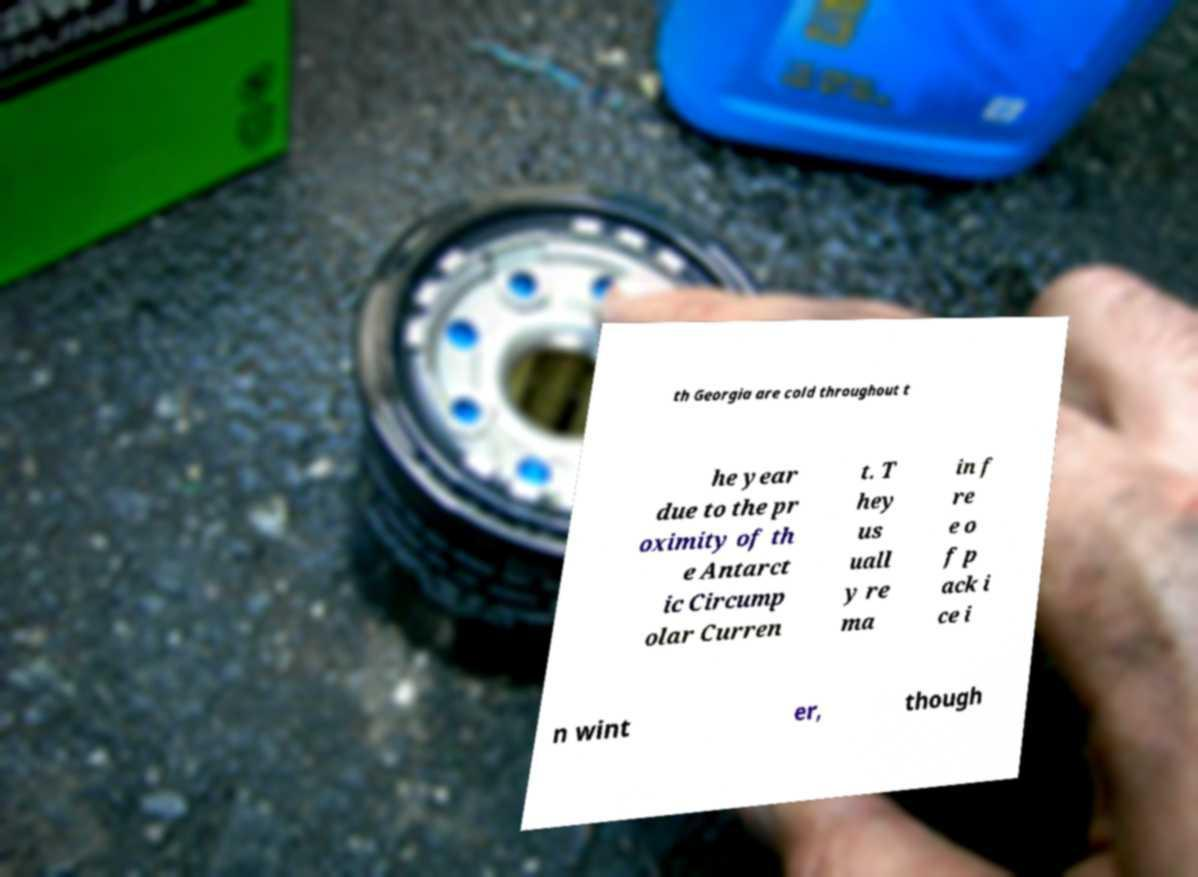Could you extract and type out the text from this image? th Georgia are cold throughout t he year due to the pr oximity of th e Antarct ic Circump olar Curren t. T hey us uall y re ma in f re e o f p ack i ce i n wint er, though 